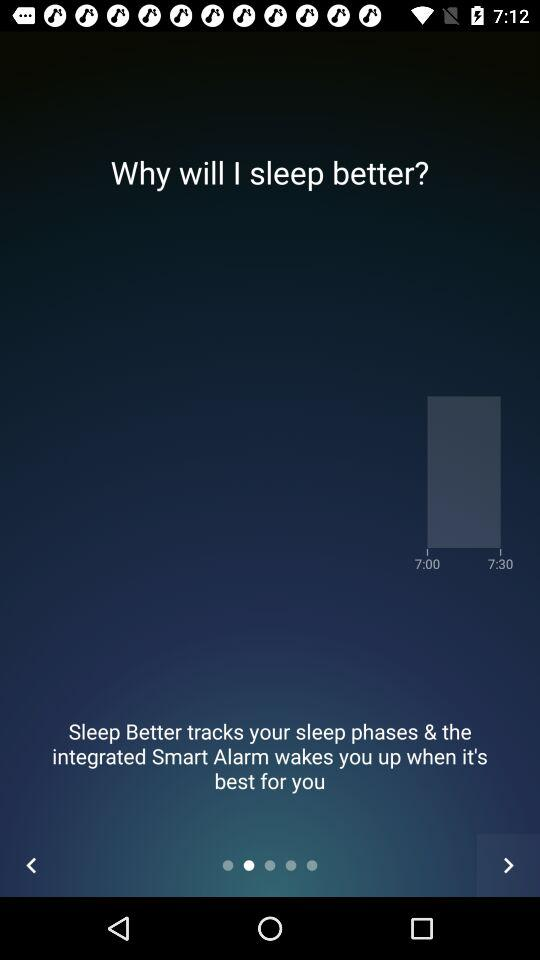What is the difference in minutes between the two wake up times?
Answer the question using a single word or phrase. 30 